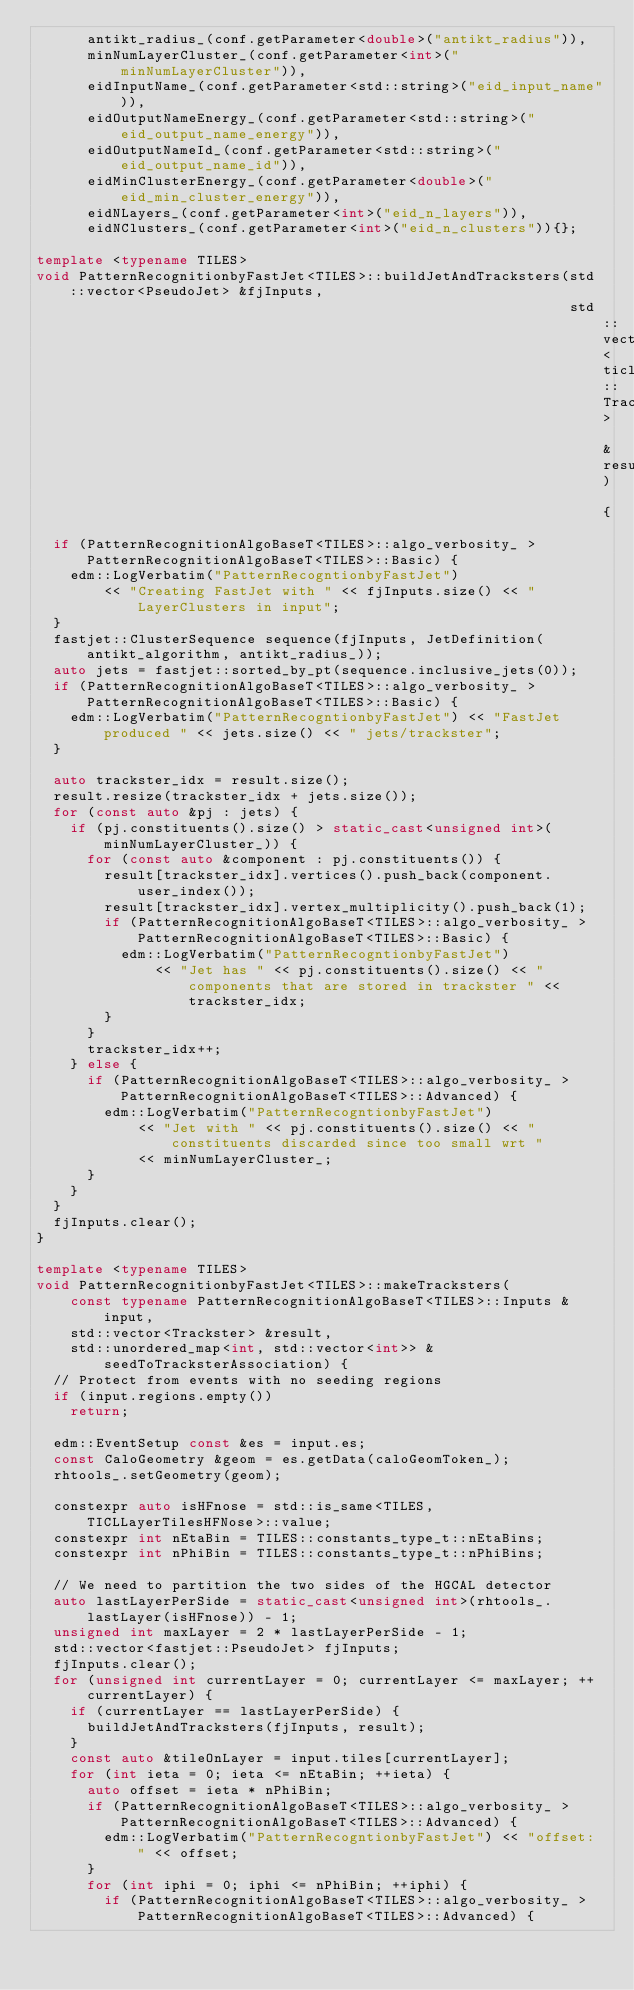Convert code to text. <code><loc_0><loc_0><loc_500><loc_500><_C++_>      antikt_radius_(conf.getParameter<double>("antikt_radius")),
      minNumLayerCluster_(conf.getParameter<int>("minNumLayerCluster")),
      eidInputName_(conf.getParameter<std::string>("eid_input_name")),
      eidOutputNameEnergy_(conf.getParameter<std::string>("eid_output_name_energy")),
      eidOutputNameId_(conf.getParameter<std::string>("eid_output_name_id")),
      eidMinClusterEnergy_(conf.getParameter<double>("eid_min_cluster_energy")),
      eidNLayers_(conf.getParameter<int>("eid_n_layers")),
      eidNClusters_(conf.getParameter<int>("eid_n_clusters")){};

template <typename TILES>
void PatternRecognitionbyFastJet<TILES>::buildJetAndTracksters(std::vector<PseudoJet> &fjInputs,
                                                               std::vector<ticl::Trackster> &result) {
  if (PatternRecognitionAlgoBaseT<TILES>::algo_verbosity_ > PatternRecognitionAlgoBaseT<TILES>::Basic) {
    edm::LogVerbatim("PatternRecogntionbyFastJet")
        << "Creating FastJet with " << fjInputs.size() << " LayerClusters in input";
  }
  fastjet::ClusterSequence sequence(fjInputs, JetDefinition(antikt_algorithm, antikt_radius_));
  auto jets = fastjet::sorted_by_pt(sequence.inclusive_jets(0));
  if (PatternRecognitionAlgoBaseT<TILES>::algo_verbosity_ > PatternRecognitionAlgoBaseT<TILES>::Basic) {
    edm::LogVerbatim("PatternRecogntionbyFastJet") << "FastJet produced " << jets.size() << " jets/trackster";
  }

  auto trackster_idx = result.size();
  result.resize(trackster_idx + jets.size());
  for (const auto &pj : jets) {
    if (pj.constituents().size() > static_cast<unsigned int>(minNumLayerCluster_)) {
      for (const auto &component : pj.constituents()) {
        result[trackster_idx].vertices().push_back(component.user_index());
        result[trackster_idx].vertex_multiplicity().push_back(1);
        if (PatternRecognitionAlgoBaseT<TILES>::algo_verbosity_ > PatternRecognitionAlgoBaseT<TILES>::Basic) {
          edm::LogVerbatim("PatternRecogntionbyFastJet")
              << "Jet has " << pj.constituents().size() << " components that are stored in trackster " << trackster_idx;
        }
      }
      trackster_idx++;
    } else {
      if (PatternRecognitionAlgoBaseT<TILES>::algo_verbosity_ > PatternRecognitionAlgoBaseT<TILES>::Advanced) {
        edm::LogVerbatim("PatternRecogntionbyFastJet")
            << "Jet with " << pj.constituents().size() << " constituents discarded since too small wrt "
            << minNumLayerCluster_;
      }
    }
  }
  fjInputs.clear();
}

template <typename TILES>
void PatternRecognitionbyFastJet<TILES>::makeTracksters(
    const typename PatternRecognitionAlgoBaseT<TILES>::Inputs &input,
    std::vector<Trackster> &result,
    std::unordered_map<int, std::vector<int>> &seedToTracksterAssociation) {
  // Protect from events with no seeding regions
  if (input.regions.empty())
    return;

  edm::EventSetup const &es = input.es;
  const CaloGeometry &geom = es.getData(caloGeomToken_);
  rhtools_.setGeometry(geom);

  constexpr auto isHFnose = std::is_same<TILES, TICLLayerTilesHFNose>::value;
  constexpr int nEtaBin = TILES::constants_type_t::nEtaBins;
  constexpr int nPhiBin = TILES::constants_type_t::nPhiBins;

  // We need to partition the two sides of the HGCAL detector
  auto lastLayerPerSide = static_cast<unsigned int>(rhtools_.lastLayer(isHFnose)) - 1;
  unsigned int maxLayer = 2 * lastLayerPerSide - 1;
  std::vector<fastjet::PseudoJet> fjInputs;
  fjInputs.clear();
  for (unsigned int currentLayer = 0; currentLayer <= maxLayer; ++currentLayer) {
    if (currentLayer == lastLayerPerSide) {
      buildJetAndTracksters(fjInputs, result);
    }
    const auto &tileOnLayer = input.tiles[currentLayer];
    for (int ieta = 0; ieta <= nEtaBin; ++ieta) {
      auto offset = ieta * nPhiBin;
      if (PatternRecognitionAlgoBaseT<TILES>::algo_verbosity_ > PatternRecognitionAlgoBaseT<TILES>::Advanced) {
        edm::LogVerbatim("PatternRecogntionbyFastJet") << "offset: " << offset;
      }
      for (int iphi = 0; iphi <= nPhiBin; ++iphi) {
        if (PatternRecognitionAlgoBaseT<TILES>::algo_verbosity_ > PatternRecognitionAlgoBaseT<TILES>::Advanced) {</code> 